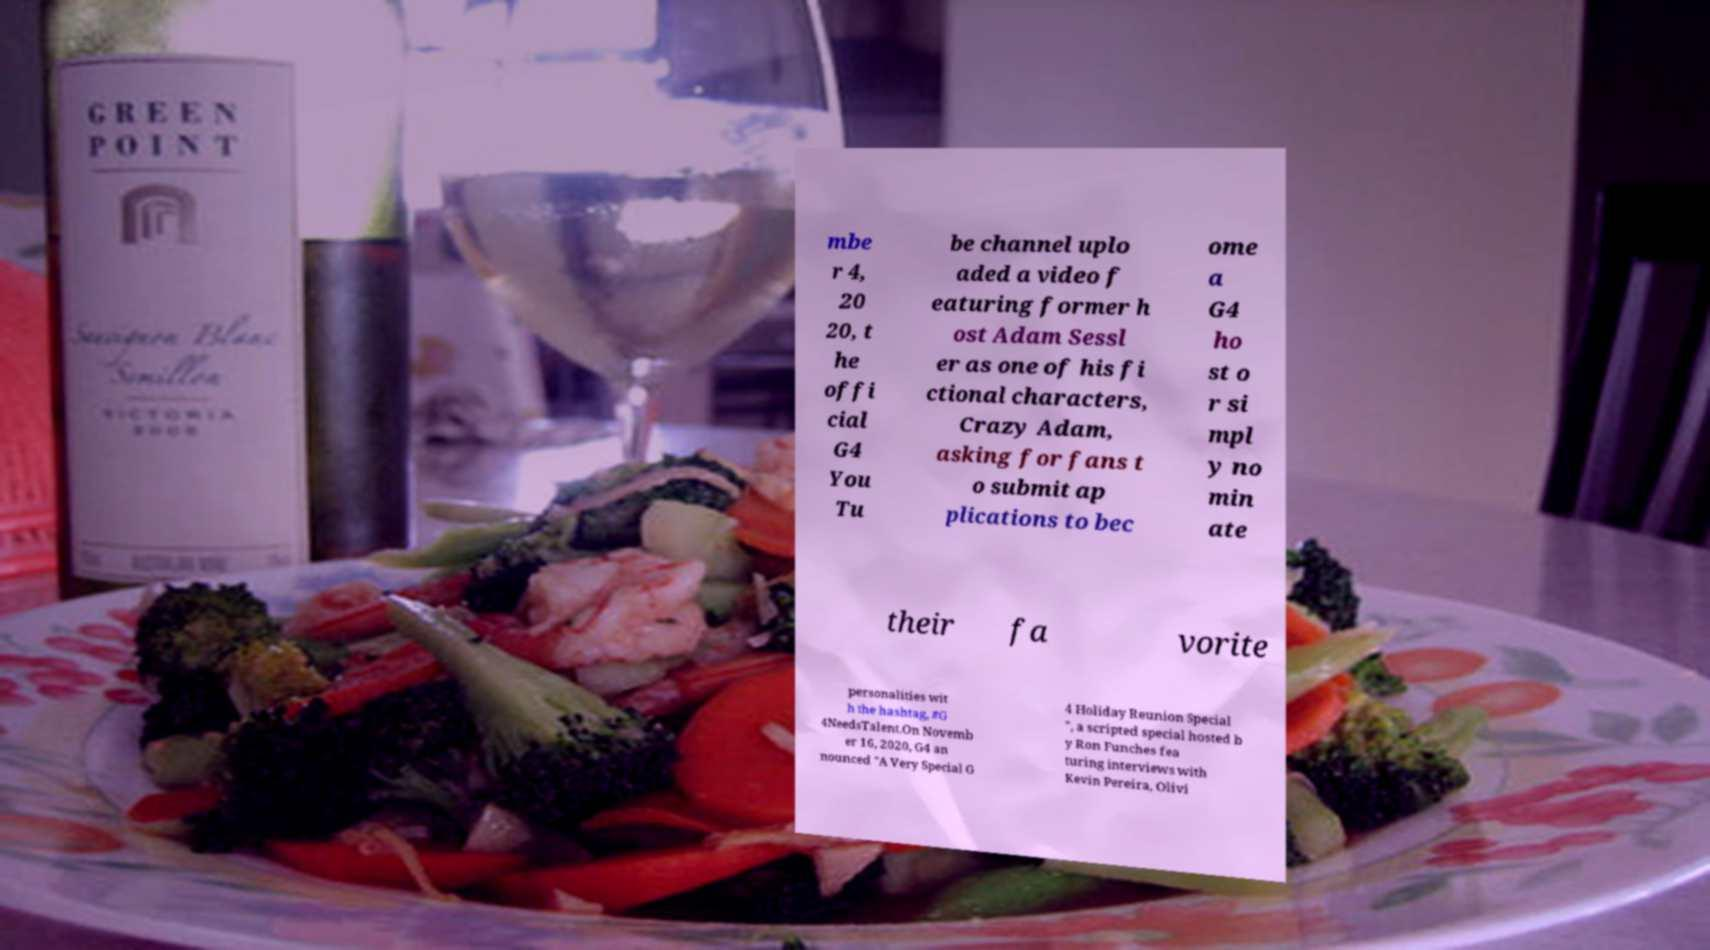For documentation purposes, I need the text within this image transcribed. Could you provide that? mbe r 4, 20 20, t he offi cial G4 You Tu be channel uplo aded a video f eaturing former h ost Adam Sessl er as one of his fi ctional characters, Crazy Adam, asking for fans t o submit ap plications to bec ome a G4 ho st o r si mpl y no min ate their fa vorite personalities wit h the hashtag, #G 4NeedsTalent.On Novemb er 16, 2020, G4 an nounced "A Very Special G 4 Holiday Reunion Special ", a scripted special hosted b y Ron Funches fea turing interviews with Kevin Pereira, Olivi 